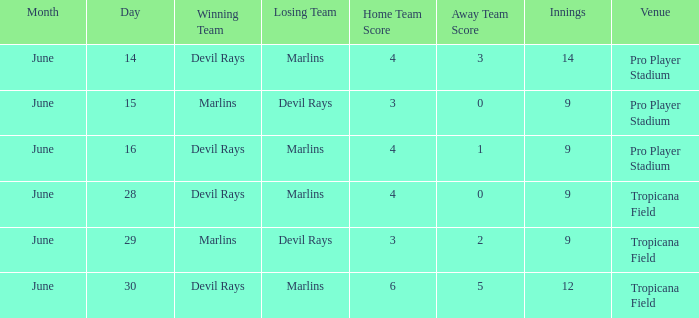What was the score on june 16? 4-1. 